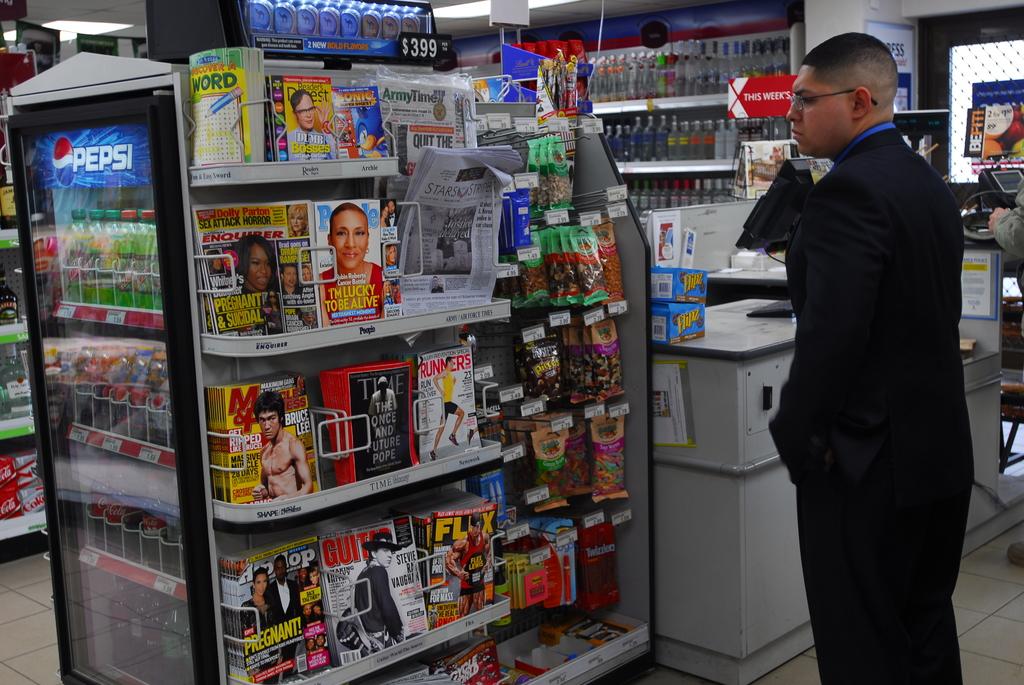What is this person staring at?
Ensure brevity in your answer.  Answering does not require reading text in the image. What drinks brand is on the fridge?
Provide a succinct answer. Pepsi. 